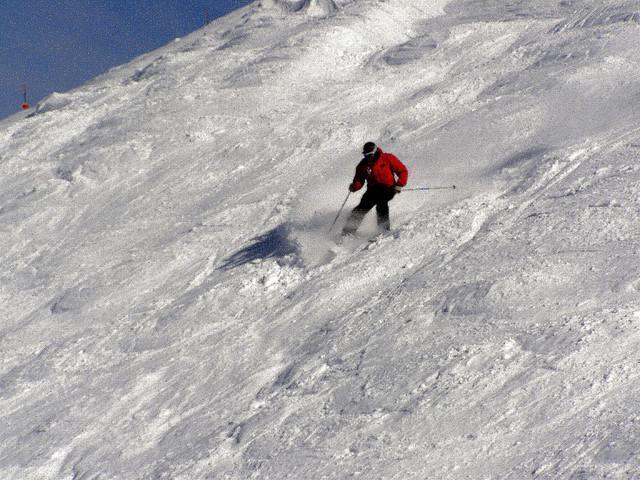How many donuts are there?
Give a very brief answer. 0. 